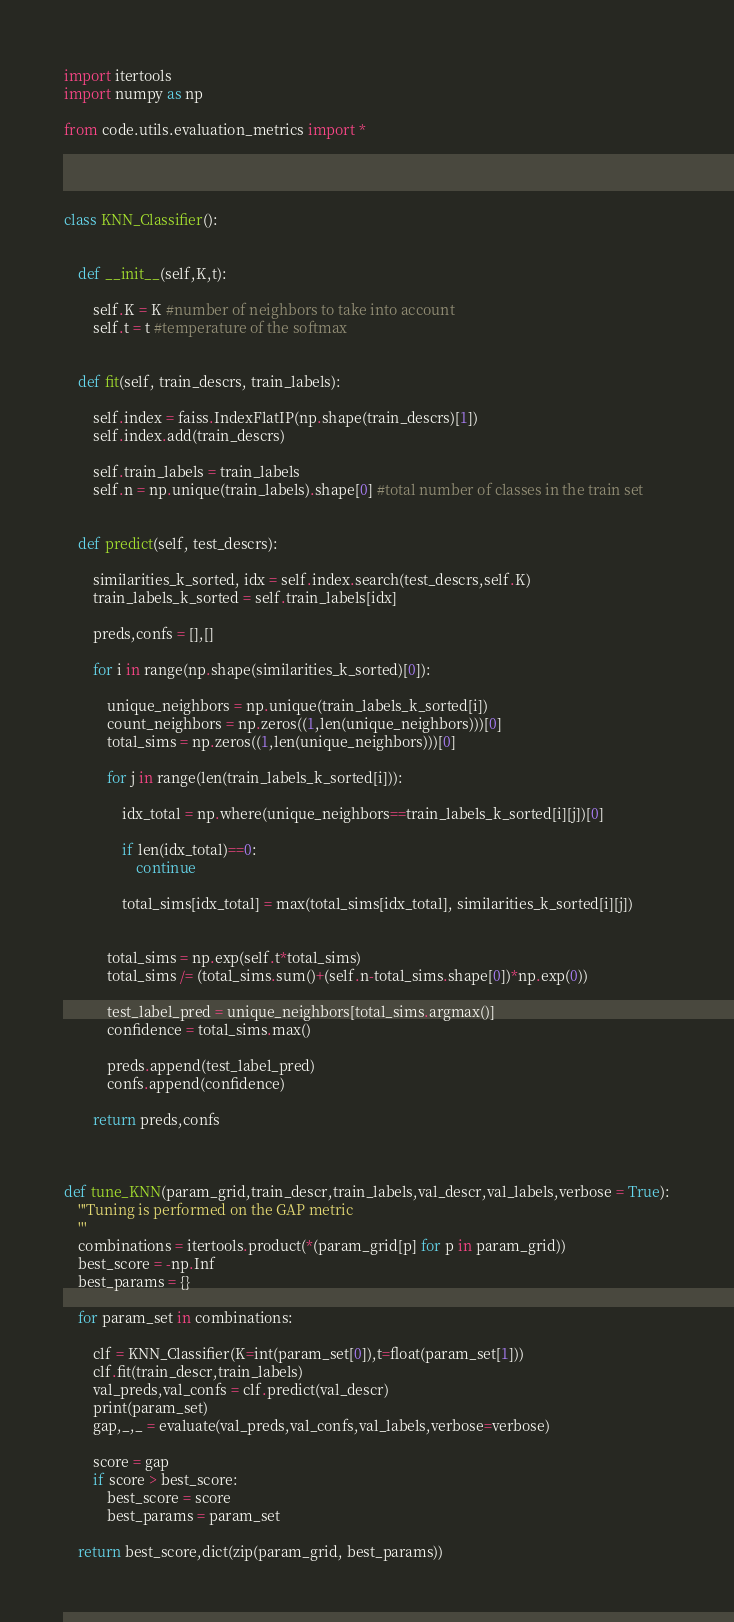Convert code to text. <code><loc_0><loc_0><loc_500><loc_500><_Python_>import itertools
import numpy as np

from code.utils.evaluation_metrics import *




class KNN_Classifier():


    def __init__(self,K,t):

        self.K = K #number of neighbors to take into account
        self.t = t #temperature of the softmax


    def fit(self, train_descrs, train_labels):

        self.index = faiss.IndexFlatIP(np.shape(train_descrs)[1])
        self.index.add(train_descrs)

        self.train_labels = train_labels
        self.n = np.unique(train_labels).shape[0] #total number of classes in the train set


    def predict(self, test_descrs):

        similarities_k_sorted, idx = self.index.search(test_descrs,self.K)
        train_labels_k_sorted = self.train_labels[idx]

        preds,confs = [],[]
        
        for i in range(np.shape(similarities_k_sorted)[0]):

            unique_neighbors = np.unique(train_labels_k_sorted[i])
            count_neighbors = np.zeros((1,len(unique_neighbors)))[0]
            total_sims = np.zeros((1,len(unique_neighbors)))[0]

            for j in range(len(train_labels_k_sorted[i])):

                idx_total = np.where(unique_neighbors==train_labels_k_sorted[i][j])[0]
                
                if len(idx_total)==0:
                    continue
                
                total_sims[idx_total] = max(total_sims[idx_total], similarities_k_sorted[i][j])

                
            total_sims = np.exp(self.t*total_sims)
            total_sims /= (total_sims.sum()+(self.n-total_sims.shape[0])*np.exp(0))

            test_label_pred = unique_neighbors[total_sims.argmax()]
            confidence = total_sims.max()

            preds.append(test_label_pred)
            confs.append(confidence)

        return preds,confs



def tune_KNN(param_grid,train_descr,train_labels,val_descr,val_labels,verbose = True):
    '''Tuning is performed on the GAP metric
    '''
    combinations = itertools.product(*(param_grid[p] for p in param_grid))
    best_score = -np.Inf
    best_params = {}

    for param_set in combinations:

        clf = KNN_Classifier(K=int(param_set[0]),t=float(param_set[1]))
        clf.fit(train_descr,train_labels)
        val_preds,val_confs = clf.predict(val_descr)
        print(param_set)
        gap,_,_ = evaluate(val_preds,val_confs,val_labels,verbose=verbose)

        score = gap
        if score > best_score:
            best_score = score
            best_params = param_set

    return best_score,dict(zip(param_grid, best_params))
</code> 